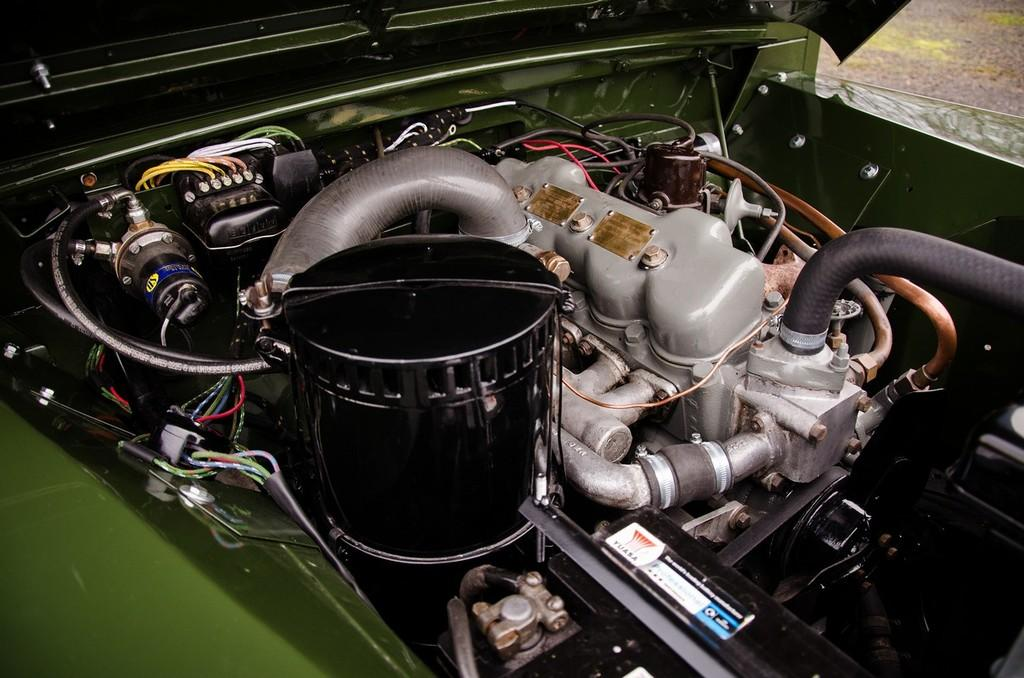What is the main subject in the foreground of the image? There is a vehicle in the foreground of the image. What specific part of the vehicle can be seen in the image? The hood of the vehicle is visible in the image. What else can be seen of the vehicle besides the hood? There are parts of the vehicle and the body of the vehicle visible in the image. What type of waste is being disposed of near the vehicle in the image? There is no waste present in the image; it only features a vehicle with its hood, parts, and body visible. 